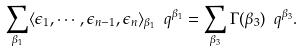<formula> <loc_0><loc_0><loc_500><loc_500>\sum _ { \beta _ { 1 } } \langle \epsilon _ { 1 } , \cdots , \epsilon _ { n - 1 } , \epsilon _ { n } \rangle _ { \beta _ { 1 } } \ q ^ { \beta _ { 1 } } = \sum _ { \beta _ { 3 } } \Gamma ( \beta _ { 3 } ) \ q ^ { \beta _ { 3 } } .</formula> 